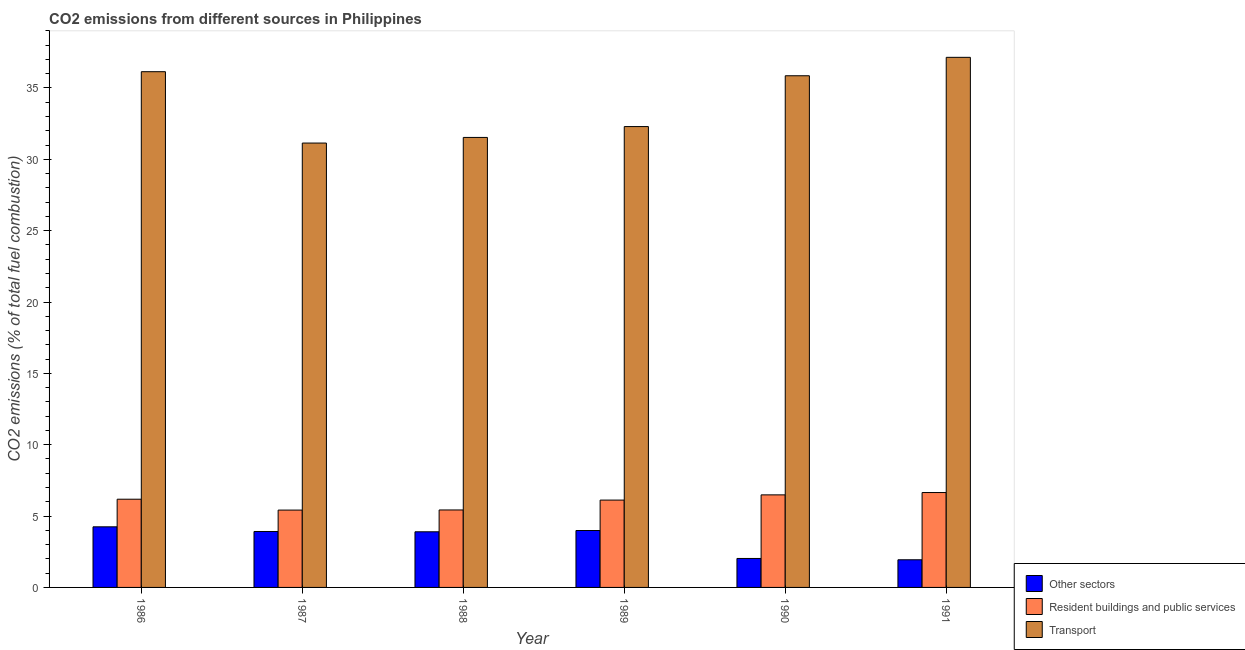How many groups of bars are there?
Your response must be concise. 6. Are the number of bars per tick equal to the number of legend labels?
Make the answer very short. Yes. Are the number of bars on each tick of the X-axis equal?
Give a very brief answer. Yes. How many bars are there on the 2nd tick from the right?
Your answer should be very brief. 3. In how many cases, is the number of bars for a given year not equal to the number of legend labels?
Your answer should be compact. 0. What is the percentage of co2 emissions from resident buildings and public services in 1988?
Your answer should be compact. 5.43. Across all years, what is the maximum percentage of co2 emissions from resident buildings and public services?
Provide a short and direct response. 6.65. Across all years, what is the minimum percentage of co2 emissions from other sectors?
Offer a very short reply. 1.94. What is the total percentage of co2 emissions from other sectors in the graph?
Your answer should be compact. 20.02. What is the difference between the percentage of co2 emissions from resident buildings and public services in 1988 and that in 1990?
Provide a short and direct response. -1.06. What is the difference between the percentage of co2 emissions from other sectors in 1987 and the percentage of co2 emissions from resident buildings and public services in 1986?
Your response must be concise. -0.33. What is the average percentage of co2 emissions from other sectors per year?
Your answer should be compact. 3.34. In the year 1991, what is the difference between the percentage of co2 emissions from resident buildings and public services and percentage of co2 emissions from transport?
Offer a terse response. 0. What is the ratio of the percentage of co2 emissions from other sectors in 1988 to that in 1990?
Ensure brevity in your answer.  1.92. Is the difference between the percentage of co2 emissions from resident buildings and public services in 1990 and 1991 greater than the difference between the percentage of co2 emissions from transport in 1990 and 1991?
Offer a very short reply. No. What is the difference between the highest and the second highest percentage of co2 emissions from transport?
Your answer should be very brief. 1.01. What is the difference between the highest and the lowest percentage of co2 emissions from resident buildings and public services?
Your answer should be compact. 1.23. What does the 2nd bar from the left in 1990 represents?
Your response must be concise. Resident buildings and public services. What does the 1st bar from the right in 1988 represents?
Your answer should be very brief. Transport. How many years are there in the graph?
Offer a very short reply. 6. Does the graph contain grids?
Offer a very short reply. No. How are the legend labels stacked?
Give a very brief answer. Vertical. What is the title of the graph?
Give a very brief answer. CO2 emissions from different sources in Philippines. What is the label or title of the Y-axis?
Your response must be concise. CO2 emissions (% of total fuel combustion). What is the CO2 emissions (% of total fuel combustion) of Other sectors in 1986?
Provide a succinct answer. 4.25. What is the CO2 emissions (% of total fuel combustion) of Resident buildings and public services in 1986?
Offer a terse response. 6.18. What is the CO2 emissions (% of total fuel combustion) of Transport in 1986?
Offer a very short reply. 36.14. What is the CO2 emissions (% of total fuel combustion) of Other sectors in 1987?
Provide a short and direct response. 3.92. What is the CO2 emissions (% of total fuel combustion) of Resident buildings and public services in 1987?
Give a very brief answer. 5.42. What is the CO2 emissions (% of total fuel combustion) in Transport in 1987?
Give a very brief answer. 31.14. What is the CO2 emissions (% of total fuel combustion) in Other sectors in 1988?
Ensure brevity in your answer.  3.9. What is the CO2 emissions (% of total fuel combustion) in Resident buildings and public services in 1988?
Keep it short and to the point. 5.43. What is the CO2 emissions (% of total fuel combustion) in Transport in 1988?
Offer a terse response. 31.53. What is the CO2 emissions (% of total fuel combustion) in Other sectors in 1989?
Make the answer very short. 3.99. What is the CO2 emissions (% of total fuel combustion) in Resident buildings and public services in 1989?
Offer a terse response. 6.12. What is the CO2 emissions (% of total fuel combustion) of Transport in 1989?
Your response must be concise. 32.3. What is the CO2 emissions (% of total fuel combustion) of Other sectors in 1990?
Offer a very short reply. 2.03. What is the CO2 emissions (% of total fuel combustion) of Resident buildings and public services in 1990?
Provide a short and direct response. 6.49. What is the CO2 emissions (% of total fuel combustion) in Transport in 1990?
Your answer should be compact. 35.86. What is the CO2 emissions (% of total fuel combustion) of Other sectors in 1991?
Provide a short and direct response. 1.94. What is the CO2 emissions (% of total fuel combustion) in Resident buildings and public services in 1991?
Provide a succinct answer. 6.65. What is the CO2 emissions (% of total fuel combustion) in Transport in 1991?
Your answer should be compact. 37.15. Across all years, what is the maximum CO2 emissions (% of total fuel combustion) of Other sectors?
Your answer should be very brief. 4.25. Across all years, what is the maximum CO2 emissions (% of total fuel combustion) in Resident buildings and public services?
Ensure brevity in your answer.  6.65. Across all years, what is the maximum CO2 emissions (% of total fuel combustion) in Transport?
Make the answer very short. 37.15. Across all years, what is the minimum CO2 emissions (% of total fuel combustion) of Other sectors?
Ensure brevity in your answer.  1.94. Across all years, what is the minimum CO2 emissions (% of total fuel combustion) of Resident buildings and public services?
Ensure brevity in your answer.  5.42. Across all years, what is the minimum CO2 emissions (% of total fuel combustion) in Transport?
Offer a very short reply. 31.14. What is the total CO2 emissions (% of total fuel combustion) in Other sectors in the graph?
Offer a terse response. 20.02. What is the total CO2 emissions (% of total fuel combustion) of Resident buildings and public services in the graph?
Provide a short and direct response. 36.28. What is the total CO2 emissions (% of total fuel combustion) in Transport in the graph?
Provide a short and direct response. 204.11. What is the difference between the CO2 emissions (% of total fuel combustion) of Other sectors in 1986 and that in 1987?
Your response must be concise. 0.33. What is the difference between the CO2 emissions (% of total fuel combustion) in Resident buildings and public services in 1986 and that in 1987?
Give a very brief answer. 0.76. What is the difference between the CO2 emissions (% of total fuel combustion) of Transport in 1986 and that in 1987?
Offer a very short reply. 5. What is the difference between the CO2 emissions (% of total fuel combustion) in Other sectors in 1986 and that in 1988?
Give a very brief answer. 0.35. What is the difference between the CO2 emissions (% of total fuel combustion) in Resident buildings and public services in 1986 and that in 1988?
Give a very brief answer. 0.75. What is the difference between the CO2 emissions (% of total fuel combustion) of Transport in 1986 and that in 1988?
Your response must be concise. 4.61. What is the difference between the CO2 emissions (% of total fuel combustion) in Other sectors in 1986 and that in 1989?
Provide a succinct answer. 0.26. What is the difference between the CO2 emissions (% of total fuel combustion) of Resident buildings and public services in 1986 and that in 1989?
Your answer should be very brief. 0.06. What is the difference between the CO2 emissions (% of total fuel combustion) of Transport in 1986 and that in 1989?
Offer a very short reply. 3.84. What is the difference between the CO2 emissions (% of total fuel combustion) in Other sectors in 1986 and that in 1990?
Offer a terse response. 2.22. What is the difference between the CO2 emissions (% of total fuel combustion) in Resident buildings and public services in 1986 and that in 1990?
Your answer should be compact. -0.3. What is the difference between the CO2 emissions (% of total fuel combustion) of Transport in 1986 and that in 1990?
Keep it short and to the point. 0.28. What is the difference between the CO2 emissions (% of total fuel combustion) in Other sectors in 1986 and that in 1991?
Provide a short and direct response. 2.31. What is the difference between the CO2 emissions (% of total fuel combustion) of Resident buildings and public services in 1986 and that in 1991?
Provide a short and direct response. -0.47. What is the difference between the CO2 emissions (% of total fuel combustion) in Transport in 1986 and that in 1991?
Offer a terse response. -1.01. What is the difference between the CO2 emissions (% of total fuel combustion) in Other sectors in 1987 and that in 1988?
Provide a succinct answer. 0.02. What is the difference between the CO2 emissions (% of total fuel combustion) of Resident buildings and public services in 1987 and that in 1988?
Ensure brevity in your answer.  -0.01. What is the difference between the CO2 emissions (% of total fuel combustion) of Transport in 1987 and that in 1988?
Your answer should be compact. -0.39. What is the difference between the CO2 emissions (% of total fuel combustion) in Other sectors in 1987 and that in 1989?
Your response must be concise. -0.07. What is the difference between the CO2 emissions (% of total fuel combustion) of Resident buildings and public services in 1987 and that in 1989?
Provide a short and direct response. -0.7. What is the difference between the CO2 emissions (% of total fuel combustion) of Transport in 1987 and that in 1989?
Make the answer very short. -1.16. What is the difference between the CO2 emissions (% of total fuel combustion) in Other sectors in 1987 and that in 1990?
Give a very brief answer. 1.89. What is the difference between the CO2 emissions (% of total fuel combustion) of Resident buildings and public services in 1987 and that in 1990?
Offer a terse response. -1.07. What is the difference between the CO2 emissions (% of total fuel combustion) of Transport in 1987 and that in 1990?
Your answer should be compact. -4.72. What is the difference between the CO2 emissions (% of total fuel combustion) in Other sectors in 1987 and that in 1991?
Make the answer very short. 1.98. What is the difference between the CO2 emissions (% of total fuel combustion) of Resident buildings and public services in 1987 and that in 1991?
Provide a short and direct response. -1.23. What is the difference between the CO2 emissions (% of total fuel combustion) of Transport in 1987 and that in 1991?
Your answer should be compact. -6.01. What is the difference between the CO2 emissions (% of total fuel combustion) of Other sectors in 1988 and that in 1989?
Give a very brief answer. -0.09. What is the difference between the CO2 emissions (% of total fuel combustion) of Resident buildings and public services in 1988 and that in 1989?
Your answer should be compact. -0.69. What is the difference between the CO2 emissions (% of total fuel combustion) of Transport in 1988 and that in 1989?
Your response must be concise. -0.76. What is the difference between the CO2 emissions (% of total fuel combustion) in Other sectors in 1988 and that in 1990?
Provide a short and direct response. 1.87. What is the difference between the CO2 emissions (% of total fuel combustion) of Resident buildings and public services in 1988 and that in 1990?
Your response must be concise. -1.06. What is the difference between the CO2 emissions (% of total fuel combustion) of Transport in 1988 and that in 1990?
Your response must be concise. -4.32. What is the difference between the CO2 emissions (% of total fuel combustion) in Other sectors in 1988 and that in 1991?
Your answer should be very brief. 1.96. What is the difference between the CO2 emissions (% of total fuel combustion) of Resident buildings and public services in 1988 and that in 1991?
Make the answer very short. -1.22. What is the difference between the CO2 emissions (% of total fuel combustion) in Transport in 1988 and that in 1991?
Make the answer very short. -5.61. What is the difference between the CO2 emissions (% of total fuel combustion) in Other sectors in 1989 and that in 1990?
Provide a succinct answer. 1.96. What is the difference between the CO2 emissions (% of total fuel combustion) of Resident buildings and public services in 1989 and that in 1990?
Give a very brief answer. -0.37. What is the difference between the CO2 emissions (% of total fuel combustion) in Transport in 1989 and that in 1990?
Your response must be concise. -3.56. What is the difference between the CO2 emissions (% of total fuel combustion) of Other sectors in 1989 and that in 1991?
Give a very brief answer. 2.05. What is the difference between the CO2 emissions (% of total fuel combustion) in Resident buildings and public services in 1989 and that in 1991?
Ensure brevity in your answer.  -0.53. What is the difference between the CO2 emissions (% of total fuel combustion) in Transport in 1989 and that in 1991?
Your response must be concise. -4.85. What is the difference between the CO2 emissions (% of total fuel combustion) in Other sectors in 1990 and that in 1991?
Your response must be concise. 0.09. What is the difference between the CO2 emissions (% of total fuel combustion) of Resident buildings and public services in 1990 and that in 1991?
Ensure brevity in your answer.  -0.16. What is the difference between the CO2 emissions (% of total fuel combustion) of Transport in 1990 and that in 1991?
Offer a very short reply. -1.29. What is the difference between the CO2 emissions (% of total fuel combustion) in Other sectors in 1986 and the CO2 emissions (% of total fuel combustion) in Resident buildings and public services in 1987?
Your answer should be compact. -1.17. What is the difference between the CO2 emissions (% of total fuel combustion) of Other sectors in 1986 and the CO2 emissions (% of total fuel combustion) of Transport in 1987?
Your response must be concise. -26.89. What is the difference between the CO2 emissions (% of total fuel combustion) in Resident buildings and public services in 1986 and the CO2 emissions (% of total fuel combustion) in Transport in 1987?
Make the answer very short. -24.96. What is the difference between the CO2 emissions (% of total fuel combustion) of Other sectors in 1986 and the CO2 emissions (% of total fuel combustion) of Resident buildings and public services in 1988?
Make the answer very short. -1.18. What is the difference between the CO2 emissions (% of total fuel combustion) of Other sectors in 1986 and the CO2 emissions (% of total fuel combustion) of Transport in 1988?
Give a very brief answer. -27.29. What is the difference between the CO2 emissions (% of total fuel combustion) of Resident buildings and public services in 1986 and the CO2 emissions (% of total fuel combustion) of Transport in 1988?
Provide a short and direct response. -25.35. What is the difference between the CO2 emissions (% of total fuel combustion) of Other sectors in 1986 and the CO2 emissions (% of total fuel combustion) of Resident buildings and public services in 1989?
Ensure brevity in your answer.  -1.87. What is the difference between the CO2 emissions (% of total fuel combustion) in Other sectors in 1986 and the CO2 emissions (% of total fuel combustion) in Transport in 1989?
Make the answer very short. -28.05. What is the difference between the CO2 emissions (% of total fuel combustion) in Resident buildings and public services in 1986 and the CO2 emissions (% of total fuel combustion) in Transport in 1989?
Give a very brief answer. -26.11. What is the difference between the CO2 emissions (% of total fuel combustion) of Other sectors in 1986 and the CO2 emissions (% of total fuel combustion) of Resident buildings and public services in 1990?
Provide a short and direct response. -2.24. What is the difference between the CO2 emissions (% of total fuel combustion) in Other sectors in 1986 and the CO2 emissions (% of total fuel combustion) in Transport in 1990?
Provide a short and direct response. -31.61. What is the difference between the CO2 emissions (% of total fuel combustion) in Resident buildings and public services in 1986 and the CO2 emissions (% of total fuel combustion) in Transport in 1990?
Your answer should be compact. -29.67. What is the difference between the CO2 emissions (% of total fuel combustion) in Other sectors in 1986 and the CO2 emissions (% of total fuel combustion) in Resident buildings and public services in 1991?
Keep it short and to the point. -2.4. What is the difference between the CO2 emissions (% of total fuel combustion) of Other sectors in 1986 and the CO2 emissions (% of total fuel combustion) of Transport in 1991?
Your answer should be very brief. -32.9. What is the difference between the CO2 emissions (% of total fuel combustion) in Resident buildings and public services in 1986 and the CO2 emissions (% of total fuel combustion) in Transport in 1991?
Provide a succinct answer. -30.97. What is the difference between the CO2 emissions (% of total fuel combustion) in Other sectors in 1987 and the CO2 emissions (% of total fuel combustion) in Resident buildings and public services in 1988?
Your response must be concise. -1.51. What is the difference between the CO2 emissions (% of total fuel combustion) in Other sectors in 1987 and the CO2 emissions (% of total fuel combustion) in Transport in 1988?
Your response must be concise. -27.61. What is the difference between the CO2 emissions (% of total fuel combustion) in Resident buildings and public services in 1987 and the CO2 emissions (% of total fuel combustion) in Transport in 1988?
Provide a succinct answer. -26.11. What is the difference between the CO2 emissions (% of total fuel combustion) in Other sectors in 1987 and the CO2 emissions (% of total fuel combustion) in Resident buildings and public services in 1989?
Your answer should be very brief. -2.2. What is the difference between the CO2 emissions (% of total fuel combustion) in Other sectors in 1987 and the CO2 emissions (% of total fuel combustion) in Transport in 1989?
Provide a short and direct response. -28.38. What is the difference between the CO2 emissions (% of total fuel combustion) in Resident buildings and public services in 1987 and the CO2 emissions (% of total fuel combustion) in Transport in 1989?
Keep it short and to the point. -26.88. What is the difference between the CO2 emissions (% of total fuel combustion) of Other sectors in 1987 and the CO2 emissions (% of total fuel combustion) of Resident buildings and public services in 1990?
Offer a very short reply. -2.57. What is the difference between the CO2 emissions (% of total fuel combustion) of Other sectors in 1987 and the CO2 emissions (% of total fuel combustion) of Transport in 1990?
Give a very brief answer. -31.94. What is the difference between the CO2 emissions (% of total fuel combustion) in Resident buildings and public services in 1987 and the CO2 emissions (% of total fuel combustion) in Transport in 1990?
Give a very brief answer. -30.44. What is the difference between the CO2 emissions (% of total fuel combustion) of Other sectors in 1987 and the CO2 emissions (% of total fuel combustion) of Resident buildings and public services in 1991?
Your response must be concise. -2.73. What is the difference between the CO2 emissions (% of total fuel combustion) of Other sectors in 1987 and the CO2 emissions (% of total fuel combustion) of Transport in 1991?
Your answer should be compact. -33.23. What is the difference between the CO2 emissions (% of total fuel combustion) in Resident buildings and public services in 1987 and the CO2 emissions (% of total fuel combustion) in Transport in 1991?
Ensure brevity in your answer.  -31.73. What is the difference between the CO2 emissions (% of total fuel combustion) in Other sectors in 1988 and the CO2 emissions (% of total fuel combustion) in Resident buildings and public services in 1989?
Make the answer very short. -2.22. What is the difference between the CO2 emissions (% of total fuel combustion) of Other sectors in 1988 and the CO2 emissions (% of total fuel combustion) of Transport in 1989?
Ensure brevity in your answer.  -28.4. What is the difference between the CO2 emissions (% of total fuel combustion) in Resident buildings and public services in 1988 and the CO2 emissions (% of total fuel combustion) in Transport in 1989?
Provide a succinct answer. -26.87. What is the difference between the CO2 emissions (% of total fuel combustion) of Other sectors in 1988 and the CO2 emissions (% of total fuel combustion) of Resident buildings and public services in 1990?
Ensure brevity in your answer.  -2.59. What is the difference between the CO2 emissions (% of total fuel combustion) in Other sectors in 1988 and the CO2 emissions (% of total fuel combustion) in Transport in 1990?
Your answer should be very brief. -31.96. What is the difference between the CO2 emissions (% of total fuel combustion) in Resident buildings and public services in 1988 and the CO2 emissions (% of total fuel combustion) in Transport in 1990?
Offer a very short reply. -30.43. What is the difference between the CO2 emissions (% of total fuel combustion) of Other sectors in 1988 and the CO2 emissions (% of total fuel combustion) of Resident buildings and public services in 1991?
Your answer should be compact. -2.75. What is the difference between the CO2 emissions (% of total fuel combustion) in Other sectors in 1988 and the CO2 emissions (% of total fuel combustion) in Transport in 1991?
Your answer should be compact. -33.25. What is the difference between the CO2 emissions (% of total fuel combustion) in Resident buildings and public services in 1988 and the CO2 emissions (% of total fuel combustion) in Transport in 1991?
Make the answer very short. -31.72. What is the difference between the CO2 emissions (% of total fuel combustion) of Other sectors in 1989 and the CO2 emissions (% of total fuel combustion) of Resident buildings and public services in 1990?
Your answer should be compact. -2.5. What is the difference between the CO2 emissions (% of total fuel combustion) in Other sectors in 1989 and the CO2 emissions (% of total fuel combustion) in Transport in 1990?
Offer a terse response. -31.87. What is the difference between the CO2 emissions (% of total fuel combustion) of Resident buildings and public services in 1989 and the CO2 emissions (% of total fuel combustion) of Transport in 1990?
Offer a terse response. -29.74. What is the difference between the CO2 emissions (% of total fuel combustion) of Other sectors in 1989 and the CO2 emissions (% of total fuel combustion) of Resident buildings and public services in 1991?
Your answer should be compact. -2.66. What is the difference between the CO2 emissions (% of total fuel combustion) of Other sectors in 1989 and the CO2 emissions (% of total fuel combustion) of Transport in 1991?
Ensure brevity in your answer.  -33.16. What is the difference between the CO2 emissions (% of total fuel combustion) of Resident buildings and public services in 1989 and the CO2 emissions (% of total fuel combustion) of Transport in 1991?
Offer a terse response. -31.03. What is the difference between the CO2 emissions (% of total fuel combustion) in Other sectors in 1990 and the CO2 emissions (% of total fuel combustion) in Resident buildings and public services in 1991?
Ensure brevity in your answer.  -4.62. What is the difference between the CO2 emissions (% of total fuel combustion) of Other sectors in 1990 and the CO2 emissions (% of total fuel combustion) of Transport in 1991?
Your answer should be compact. -35.12. What is the difference between the CO2 emissions (% of total fuel combustion) in Resident buildings and public services in 1990 and the CO2 emissions (% of total fuel combustion) in Transport in 1991?
Your answer should be very brief. -30.66. What is the average CO2 emissions (% of total fuel combustion) in Other sectors per year?
Ensure brevity in your answer.  3.34. What is the average CO2 emissions (% of total fuel combustion) in Resident buildings and public services per year?
Your response must be concise. 6.05. What is the average CO2 emissions (% of total fuel combustion) in Transport per year?
Ensure brevity in your answer.  34.02. In the year 1986, what is the difference between the CO2 emissions (% of total fuel combustion) in Other sectors and CO2 emissions (% of total fuel combustion) in Resident buildings and public services?
Offer a very short reply. -1.93. In the year 1986, what is the difference between the CO2 emissions (% of total fuel combustion) of Other sectors and CO2 emissions (% of total fuel combustion) of Transport?
Ensure brevity in your answer.  -31.89. In the year 1986, what is the difference between the CO2 emissions (% of total fuel combustion) in Resident buildings and public services and CO2 emissions (% of total fuel combustion) in Transport?
Your answer should be compact. -29.96. In the year 1987, what is the difference between the CO2 emissions (% of total fuel combustion) of Other sectors and CO2 emissions (% of total fuel combustion) of Resident buildings and public services?
Your answer should be compact. -1.5. In the year 1987, what is the difference between the CO2 emissions (% of total fuel combustion) in Other sectors and CO2 emissions (% of total fuel combustion) in Transport?
Make the answer very short. -27.22. In the year 1987, what is the difference between the CO2 emissions (% of total fuel combustion) of Resident buildings and public services and CO2 emissions (% of total fuel combustion) of Transport?
Make the answer very short. -25.72. In the year 1988, what is the difference between the CO2 emissions (% of total fuel combustion) in Other sectors and CO2 emissions (% of total fuel combustion) in Resident buildings and public services?
Provide a short and direct response. -1.53. In the year 1988, what is the difference between the CO2 emissions (% of total fuel combustion) in Other sectors and CO2 emissions (% of total fuel combustion) in Transport?
Provide a succinct answer. -27.64. In the year 1988, what is the difference between the CO2 emissions (% of total fuel combustion) of Resident buildings and public services and CO2 emissions (% of total fuel combustion) of Transport?
Provide a succinct answer. -26.1. In the year 1989, what is the difference between the CO2 emissions (% of total fuel combustion) of Other sectors and CO2 emissions (% of total fuel combustion) of Resident buildings and public services?
Offer a terse response. -2.13. In the year 1989, what is the difference between the CO2 emissions (% of total fuel combustion) of Other sectors and CO2 emissions (% of total fuel combustion) of Transport?
Give a very brief answer. -28.31. In the year 1989, what is the difference between the CO2 emissions (% of total fuel combustion) of Resident buildings and public services and CO2 emissions (% of total fuel combustion) of Transport?
Your answer should be compact. -26.17. In the year 1990, what is the difference between the CO2 emissions (% of total fuel combustion) of Other sectors and CO2 emissions (% of total fuel combustion) of Resident buildings and public services?
Your response must be concise. -4.46. In the year 1990, what is the difference between the CO2 emissions (% of total fuel combustion) of Other sectors and CO2 emissions (% of total fuel combustion) of Transport?
Make the answer very short. -33.83. In the year 1990, what is the difference between the CO2 emissions (% of total fuel combustion) of Resident buildings and public services and CO2 emissions (% of total fuel combustion) of Transport?
Provide a short and direct response. -29.37. In the year 1991, what is the difference between the CO2 emissions (% of total fuel combustion) of Other sectors and CO2 emissions (% of total fuel combustion) of Resident buildings and public services?
Give a very brief answer. -4.71. In the year 1991, what is the difference between the CO2 emissions (% of total fuel combustion) of Other sectors and CO2 emissions (% of total fuel combustion) of Transport?
Make the answer very short. -35.21. In the year 1991, what is the difference between the CO2 emissions (% of total fuel combustion) in Resident buildings and public services and CO2 emissions (% of total fuel combustion) in Transport?
Ensure brevity in your answer.  -30.5. What is the ratio of the CO2 emissions (% of total fuel combustion) of Other sectors in 1986 to that in 1987?
Your answer should be compact. 1.08. What is the ratio of the CO2 emissions (% of total fuel combustion) of Resident buildings and public services in 1986 to that in 1987?
Provide a short and direct response. 1.14. What is the ratio of the CO2 emissions (% of total fuel combustion) of Transport in 1986 to that in 1987?
Offer a terse response. 1.16. What is the ratio of the CO2 emissions (% of total fuel combustion) in Other sectors in 1986 to that in 1988?
Provide a succinct answer. 1.09. What is the ratio of the CO2 emissions (% of total fuel combustion) of Resident buildings and public services in 1986 to that in 1988?
Provide a succinct answer. 1.14. What is the ratio of the CO2 emissions (% of total fuel combustion) in Transport in 1986 to that in 1988?
Offer a very short reply. 1.15. What is the ratio of the CO2 emissions (% of total fuel combustion) in Other sectors in 1986 to that in 1989?
Offer a terse response. 1.06. What is the ratio of the CO2 emissions (% of total fuel combustion) in Resident buildings and public services in 1986 to that in 1989?
Your answer should be compact. 1.01. What is the ratio of the CO2 emissions (% of total fuel combustion) of Transport in 1986 to that in 1989?
Offer a very short reply. 1.12. What is the ratio of the CO2 emissions (% of total fuel combustion) in Other sectors in 1986 to that in 1990?
Your answer should be very brief. 2.09. What is the ratio of the CO2 emissions (% of total fuel combustion) in Resident buildings and public services in 1986 to that in 1990?
Your answer should be very brief. 0.95. What is the ratio of the CO2 emissions (% of total fuel combustion) in Transport in 1986 to that in 1990?
Your answer should be very brief. 1.01. What is the ratio of the CO2 emissions (% of total fuel combustion) of Other sectors in 1986 to that in 1991?
Offer a very short reply. 2.19. What is the ratio of the CO2 emissions (% of total fuel combustion) in Resident buildings and public services in 1986 to that in 1991?
Provide a short and direct response. 0.93. What is the ratio of the CO2 emissions (% of total fuel combustion) in Transport in 1986 to that in 1991?
Keep it short and to the point. 0.97. What is the ratio of the CO2 emissions (% of total fuel combustion) of Other sectors in 1987 to that in 1988?
Provide a succinct answer. 1.01. What is the ratio of the CO2 emissions (% of total fuel combustion) of Resident buildings and public services in 1987 to that in 1988?
Provide a succinct answer. 1. What is the ratio of the CO2 emissions (% of total fuel combustion) in Transport in 1987 to that in 1988?
Keep it short and to the point. 0.99. What is the ratio of the CO2 emissions (% of total fuel combustion) of Other sectors in 1987 to that in 1989?
Your response must be concise. 0.98. What is the ratio of the CO2 emissions (% of total fuel combustion) in Resident buildings and public services in 1987 to that in 1989?
Your answer should be compact. 0.89. What is the ratio of the CO2 emissions (% of total fuel combustion) of Transport in 1987 to that in 1989?
Ensure brevity in your answer.  0.96. What is the ratio of the CO2 emissions (% of total fuel combustion) in Other sectors in 1987 to that in 1990?
Keep it short and to the point. 1.93. What is the ratio of the CO2 emissions (% of total fuel combustion) of Resident buildings and public services in 1987 to that in 1990?
Make the answer very short. 0.84. What is the ratio of the CO2 emissions (% of total fuel combustion) of Transport in 1987 to that in 1990?
Offer a terse response. 0.87. What is the ratio of the CO2 emissions (% of total fuel combustion) of Other sectors in 1987 to that in 1991?
Your answer should be very brief. 2.02. What is the ratio of the CO2 emissions (% of total fuel combustion) of Resident buildings and public services in 1987 to that in 1991?
Provide a short and direct response. 0.82. What is the ratio of the CO2 emissions (% of total fuel combustion) of Transport in 1987 to that in 1991?
Keep it short and to the point. 0.84. What is the ratio of the CO2 emissions (% of total fuel combustion) in Other sectors in 1988 to that in 1989?
Give a very brief answer. 0.98. What is the ratio of the CO2 emissions (% of total fuel combustion) in Resident buildings and public services in 1988 to that in 1989?
Your response must be concise. 0.89. What is the ratio of the CO2 emissions (% of total fuel combustion) in Transport in 1988 to that in 1989?
Give a very brief answer. 0.98. What is the ratio of the CO2 emissions (% of total fuel combustion) in Other sectors in 1988 to that in 1990?
Offer a terse response. 1.92. What is the ratio of the CO2 emissions (% of total fuel combustion) in Resident buildings and public services in 1988 to that in 1990?
Make the answer very short. 0.84. What is the ratio of the CO2 emissions (% of total fuel combustion) in Transport in 1988 to that in 1990?
Provide a short and direct response. 0.88. What is the ratio of the CO2 emissions (% of total fuel combustion) in Other sectors in 1988 to that in 1991?
Offer a very short reply. 2.01. What is the ratio of the CO2 emissions (% of total fuel combustion) of Resident buildings and public services in 1988 to that in 1991?
Offer a very short reply. 0.82. What is the ratio of the CO2 emissions (% of total fuel combustion) of Transport in 1988 to that in 1991?
Provide a short and direct response. 0.85. What is the ratio of the CO2 emissions (% of total fuel combustion) of Other sectors in 1989 to that in 1990?
Offer a very short reply. 1.97. What is the ratio of the CO2 emissions (% of total fuel combustion) of Resident buildings and public services in 1989 to that in 1990?
Keep it short and to the point. 0.94. What is the ratio of the CO2 emissions (% of total fuel combustion) of Transport in 1989 to that in 1990?
Keep it short and to the point. 0.9. What is the ratio of the CO2 emissions (% of total fuel combustion) of Other sectors in 1989 to that in 1991?
Provide a short and direct response. 2.06. What is the ratio of the CO2 emissions (% of total fuel combustion) of Resident buildings and public services in 1989 to that in 1991?
Your answer should be very brief. 0.92. What is the ratio of the CO2 emissions (% of total fuel combustion) of Transport in 1989 to that in 1991?
Offer a terse response. 0.87. What is the ratio of the CO2 emissions (% of total fuel combustion) in Other sectors in 1990 to that in 1991?
Your answer should be compact. 1.05. What is the ratio of the CO2 emissions (% of total fuel combustion) in Resident buildings and public services in 1990 to that in 1991?
Provide a short and direct response. 0.98. What is the ratio of the CO2 emissions (% of total fuel combustion) in Transport in 1990 to that in 1991?
Your answer should be very brief. 0.97. What is the difference between the highest and the second highest CO2 emissions (% of total fuel combustion) of Other sectors?
Give a very brief answer. 0.26. What is the difference between the highest and the second highest CO2 emissions (% of total fuel combustion) of Resident buildings and public services?
Ensure brevity in your answer.  0.16. What is the difference between the highest and the second highest CO2 emissions (% of total fuel combustion) in Transport?
Offer a very short reply. 1.01. What is the difference between the highest and the lowest CO2 emissions (% of total fuel combustion) in Other sectors?
Provide a short and direct response. 2.31. What is the difference between the highest and the lowest CO2 emissions (% of total fuel combustion) in Resident buildings and public services?
Your response must be concise. 1.23. What is the difference between the highest and the lowest CO2 emissions (% of total fuel combustion) of Transport?
Provide a succinct answer. 6.01. 